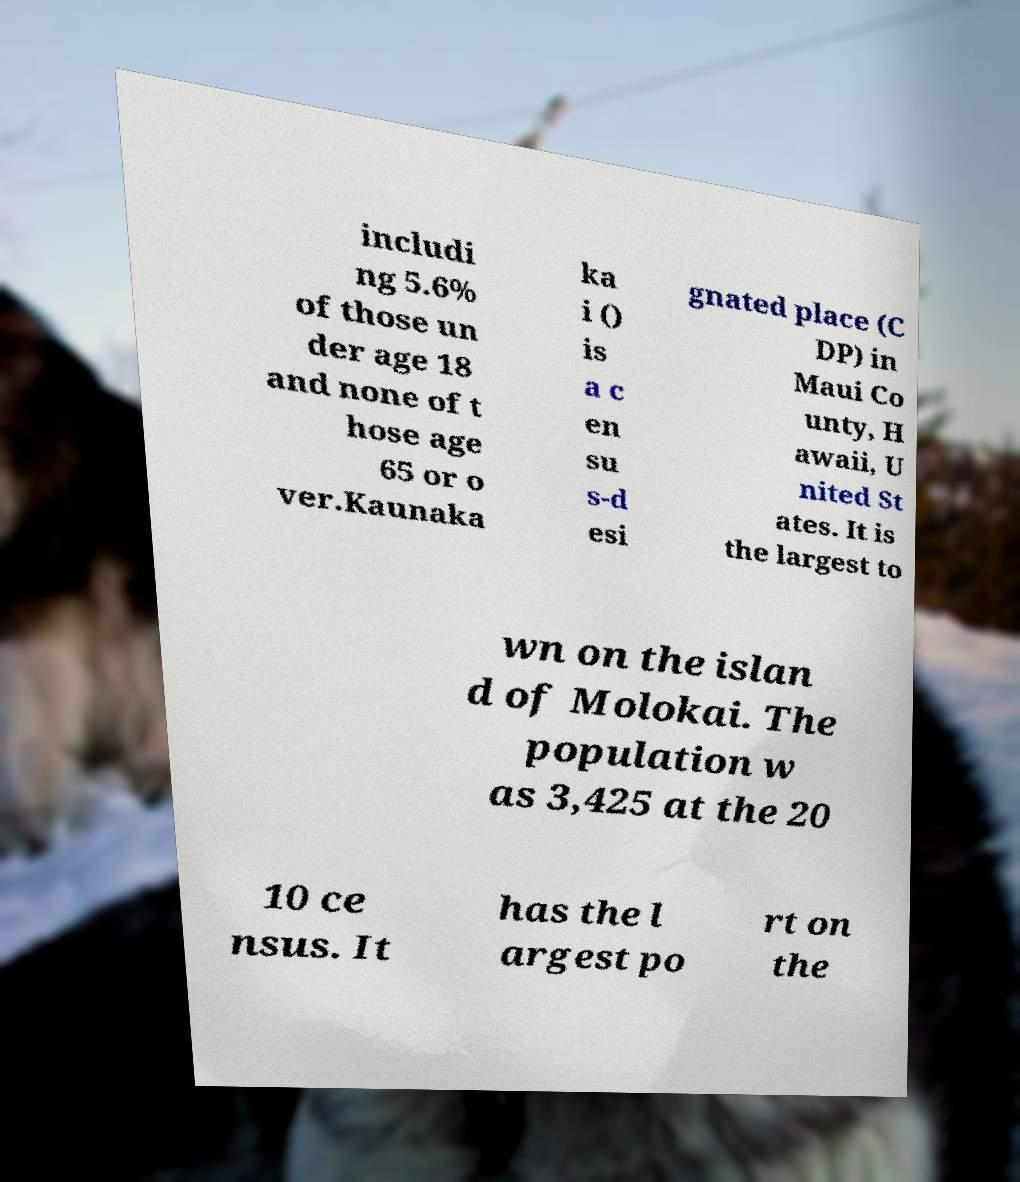Please identify and transcribe the text found in this image. includi ng 5.6% of those un der age 18 and none of t hose age 65 or o ver.Kaunaka ka i () is a c en su s-d esi gnated place (C DP) in Maui Co unty, H awaii, U nited St ates. It is the largest to wn on the islan d of Molokai. The population w as 3,425 at the 20 10 ce nsus. It has the l argest po rt on the 